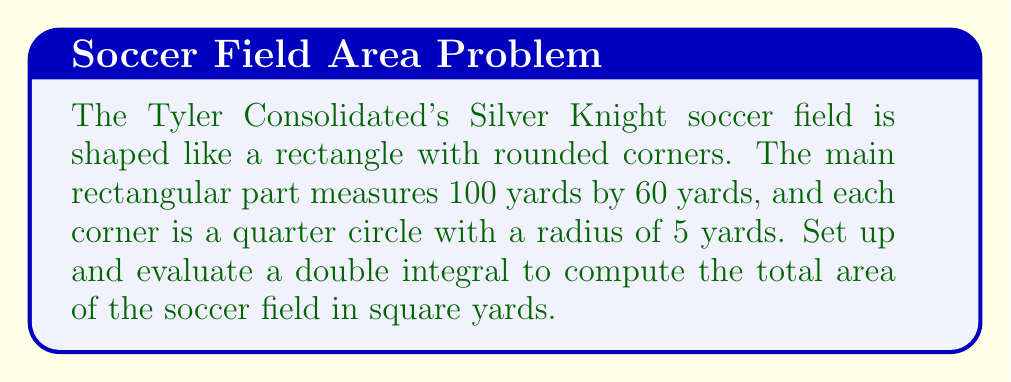Could you help me with this problem? Let's approach this step-by-step:

1) First, we need to set up our coordinate system. Let's place the origin at the center of the field, with the x-axis along the length and the y-axis along the width.

2) The field can be divided into three parts:
   a) The main rectangular part
   b) The rounded corners (four quarter circles)

3) For the main rectangular part:
   Length: 100 yards, so x ranges from -50 to 50
   Width: 60 yards, so y ranges from -30 to 30

4) The double integral for the rectangular part:

   $$A_1 = \int_{-30}^{30} \int_{-50}^{50} 1 \, dx \, dy$$

5) For the rounded corners, we need to subtract the area of four 5x5 squares and add the area of four quarter circles.

6) The area to subtract:

   $$A_2 = 4 * (5 * 5) = 100 \text{ sq yards}$$

7) The area to add (four quarter circles):

   $$A_3 = 4 * \int_{0}^{5} \int_{0}^{\sqrt{25-y^2}} 1 \, dx \, dy$$

8) The total area is:

   $$A_{total} = A_1 - A_2 + A_3$$

9) Evaluating $A_1$:
   $$A_1 = \int_{-30}^{30} \int_{-50}^{50} 1 \, dx \, dy = 100 * 60 = 6000 \text{ sq yards}$$

10) Evaluating $A_3$:
    $$A_3 = 4 * \int_{0}^{5} \int_{0}^{\sqrt{25-y^2}} 1 \, dx \, dy = 4 * \frac{\pi r^2}{4} = \pi r^2 = \pi * 5^2 = 25\pi \text{ sq yards}$$

11) Therefore, the total area is:
    $$A_{total} = 6000 - 100 + 25\pi \approx 5978.54 \text{ sq yards}$$
Answer: $5978.54 \text{ sq yards}$ 